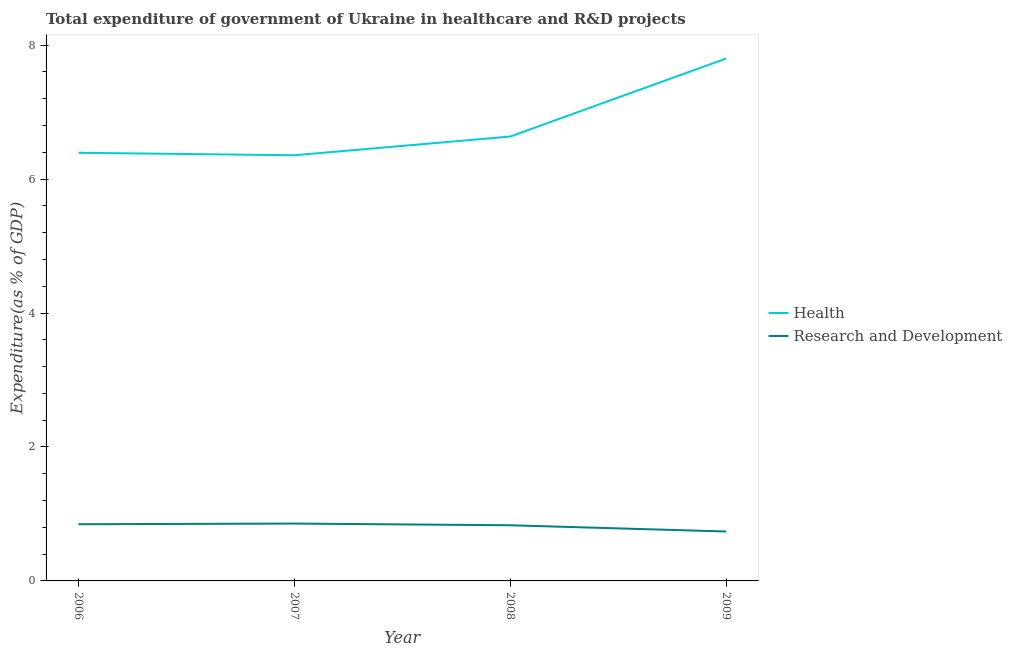How many different coloured lines are there?
Give a very brief answer. 2. What is the expenditure in r&d in 2008?
Keep it short and to the point. 0.83. Across all years, what is the maximum expenditure in healthcare?
Your answer should be compact. 7.8. Across all years, what is the minimum expenditure in r&d?
Offer a very short reply. 0.74. In which year was the expenditure in r&d minimum?
Ensure brevity in your answer.  2009. What is the total expenditure in r&d in the graph?
Ensure brevity in your answer.  3.27. What is the difference between the expenditure in r&d in 2006 and that in 2008?
Give a very brief answer. 0.02. What is the difference between the expenditure in healthcare in 2009 and the expenditure in r&d in 2006?
Provide a succinct answer. 6.95. What is the average expenditure in r&d per year?
Your response must be concise. 0.82. In the year 2007, what is the difference between the expenditure in r&d and expenditure in healthcare?
Give a very brief answer. -5.5. In how many years, is the expenditure in r&d greater than 6.4 %?
Ensure brevity in your answer.  0. What is the ratio of the expenditure in r&d in 2007 to that in 2008?
Give a very brief answer. 1.03. Is the difference between the expenditure in r&d in 2007 and 2009 greater than the difference between the expenditure in healthcare in 2007 and 2009?
Offer a terse response. Yes. What is the difference between the highest and the second highest expenditure in healthcare?
Provide a short and direct response. 1.17. What is the difference between the highest and the lowest expenditure in r&d?
Offer a very short reply. 0.12. In how many years, is the expenditure in healthcare greater than the average expenditure in healthcare taken over all years?
Keep it short and to the point. 1. Is the sum of the expenditure in r&d in 2007 and 2009 greater than the maximum expenditure in healthcare across all years?
Make the answer very short. No. Is the expenditure in r&d strictly less than the expenditure in healthcare over the years?
Keep it short and to the point. Yes. How many lines are there?
Provide a short and direct response. 2. What is the difference between two consecutive major ticks on the Y-axis?
Your response must be concise. 2. Does the graph contain any zero values?
Provide a short and direct response. No. Does the graph contain grids?
Offer a terse response. No. Where does the legend appear in the graph?
Provide a succinct answer. Center right. How many legend labels are there?
Make the answer very short. 2. What is the title of the graph?
Your response must be concise. Total expenditure of government of Ukraine in healthcare and R&D projects. Does "Private funds" appear as one of the legend labels in the graph?
Offer a very short reply. No. What is the label or title of the X-axis?
Provide a short and direct response. Year. What is the label or title of the Y-axis?
Ensure brevity in your answer.  Expenditure(as % of GDP). What is the Expenditure(as % of GDP) of Health in 2006?
Ensure brevity in your answer.  6.39. What is the Expenditure(as % of GDP) in Research and Development in 2006?
Ensure brevity in your answer.  0.85. What is the Expenditure(as % of GDP) of Health in 2007?
Offer a very short reply. 6.36. What is the Expenditure(as % of GDP) of Research and Development in 2007?
Provide a short and direct response. 0.86. What is the Expenditure(as % of GDP) of Health in 2008?
Your answer should be compact. 6.63. What is the Expenditure(as % of GDP) in Research and Development in 2008?
Offer a very short reply. 0.83. What is the Expenditure(as % of GDP) of Health in 2009?
Your answer should be compact. 7.8. What is the Expenditure(as % of GDP) in Research and Development in 2009?
Ensure brevity in your answer.  0.74. Across all years, what is the maximum Expenditure(as % of GDP) of Health?
Your response must be concise. 7.8. Across all years, what is the maximum Expenditure(as % of GDP) in Research and Development?
Your answer should be very brief. 0.86. Across all years, what is the minimum Expenditure(as % of GDP) of Health?
Your response must be concise. 6.36. Across all years, what is the minimum Expenditure(as % of GDP) in Research and Development?
Offer a very short reply. 0.74. What is the total Expenditure(as % of GDP) in Health in the graph?
Offer a very short reply. 27.18. What is the total Expenditure(as % of GDP) in Research and Development in the graph?
Provide a succinct answer. 3.27. What is the difference between the Expenditure(as % of GDP) of Health in 2006 and that in 2007?
Offer a very short reply. 0.04. What is the difference between the Expenditure(as % of GDP) of Research and Development in 2006 and that in 2007?
Offer a very short reply. -0.01. What is the difference between the Expenditure(as % of GDP) of Health in 2006 and that in 2008?
Give a very brief answer. -0.24. What is the difference between the Expenditure(as % of GDP) in Research and Development in 2006 and that in 2008?
Your answer should be very brief. 0.02. What is the difference between the Expenditure(as % of GDP) in Health in 2006 and that in 2009?
Ensure brevity in your answer.  -1.41. What is the difference between the Expenditure(as % of GDP) in Research and Development in 2006 and that in 2009?
Provide a short and direct response. 0.11. What is the difference between the Expenditure(as % of GDP) of Health in 2007 and that in 2008?
Your answer should be compact. -0.28. What is the difference between the Expenditure(as % of GDP) of Research and Development in 2007 and that in 2008?
Provide a short and direct response. 0.03. What is the difference between the Expenditure(as % of GDP) in Health in 2007 and that in 2009?
Your answer should be very brief. -1.44. What is the difference between the Expenditure(as % of GDP) in Research and Development in 2007 and that in 2009?
Offer a very short reply. 0.12. What is the difference between the Expenditure(as % of GDP) in Health in 2008 and that in 2009?
Keep it short and to the point. -1.17. What is the difference between the Expenditure(as % of GDP) in Research and Development in 2008 and that in 2009?
Keep it short and to the point. 0.09. What is the difference between the Expenditure(as % of GDP) in Health in 2006 and the Expenditure(as % of GDP) in Research and Development in 2007?
Give a very brief answer. 5.54. What is the difference between the Expenditure(as % of GDP) of Health in 2006 and the Expenditure(as % of GDP) of Research and Development in 2008?
Keep it short and to the point. 5.56. What is the difference between the Expenditure(as % of GDP) in Health in 2006 and the Expenditure(as % of GDP) in Research and Development in 2009?
Offer a terse response. 5.65. What is the difference between the Expenditure(as % of GDP) in Health in 2007 and the Expenditure(as % of GDP) in Research and Development in 2008?
Your answer should be very brief. 5.52. What is the difference between the Expenditure(as % of GDP) of Health in 2007 and the Expenditure(as % of GDP) of Research and Development in 2009?
Your response must be concise. 5.62. What is the difference between the Expenditure(as % of GDP) of Health in 2008 and the Expenditure(as % of GDP) of Research and Development in 2009?
Your response must be concise. 5.9. What is the average Expenditure(as % of GDP) of Health per year?
Offer a terse response. 6.8. What is the average Expenditure(as % of GDP) in Research and Development per year?
Make the answer very short. 0.82. In the year 2006, what is the difference between the Expenditure(as % of GDP) in Health and Expenditure(as % of GDP) in Research and Development?
Make the answer very short. 5.55. In the year 2007, what is the difference between the Expenditure(as % of GDP) of Health and Expenditure(as % of GDP) of Research and Development?
Provide a succinct answer. 5.5. In the year 2008, what is the difference between the Expenditure(as % of GDP) in Health and Expenditure(as % of GDP) in Research and Development?
Offer a very short reply. 5.8. In the year 2009, what is the difference between the Expenditure(as % of GDP) of Health and Expenditure(as % of GDP) of Research and Development?
Provide a short and direct response. 7.06. What is the ratio of the Expenditure(as % of GDP) of Research and Development in 2006 to that in 2007?
Offer a very short reply. 0.99. What is the ratio of the Expenditure(as % of GDP) in Health in 2006 to that in 2008?
Your answer should be compact. 0.96. What is the ratio of the Expenditure(as % of GDP) of Research and Development in 2006 to that in 2008?
Provide a succinct answer. 1.02. What is the ratio of the Expenditure(as % of GDP) of Health in 2006 to that in 2009?
Your response must be concise. 0.82. What is the ratio of the Expenditure(as % of GDP) of Research and Development in 2006 to that in 2009?
Give a very brief answer. 1.15. What is the ratio of the Expenditure(as % of GDP) of Health in 2007 to that in 2008?
Make the answer very short. 0.96. What is the ratio of the Expenditure(as % of GDP) in Research and Development in 2007 to that in 2008?
Your answer should be compact. 1.03. What is the ratio of the Expenditure(as % of GDP) of Health in 2007 to that in 2009?
Your response must be concise. 0.81. What is the ratio of the Expenditure(as % of GDP) of Research and Development in 2007 to that in 2009?
Offer a very short reply. 1.16. What is the ratio of the Expenditure(as % of GDP) in Health in 2008 to that in 2009?
Your answer should be very brief. 0.85. What is the ratio of the Expenditure(as % of GDP) in Research and Development in 2008 to that in 2009?
Make the answer very short. 1.13. What is the difference between the highest and the second highest Expenditure(as % of GDP) in Health?
Your answer should be very brief. 1.17. What is the difference between the highest and the lowest Expenditure(as % of GDP) in Health?
Make the answer very short. 1.44. What is the difference between the highest and the lowest Expenditure(as % of GDP) of Research and Development?
Your answer should be compact. 0.12. 